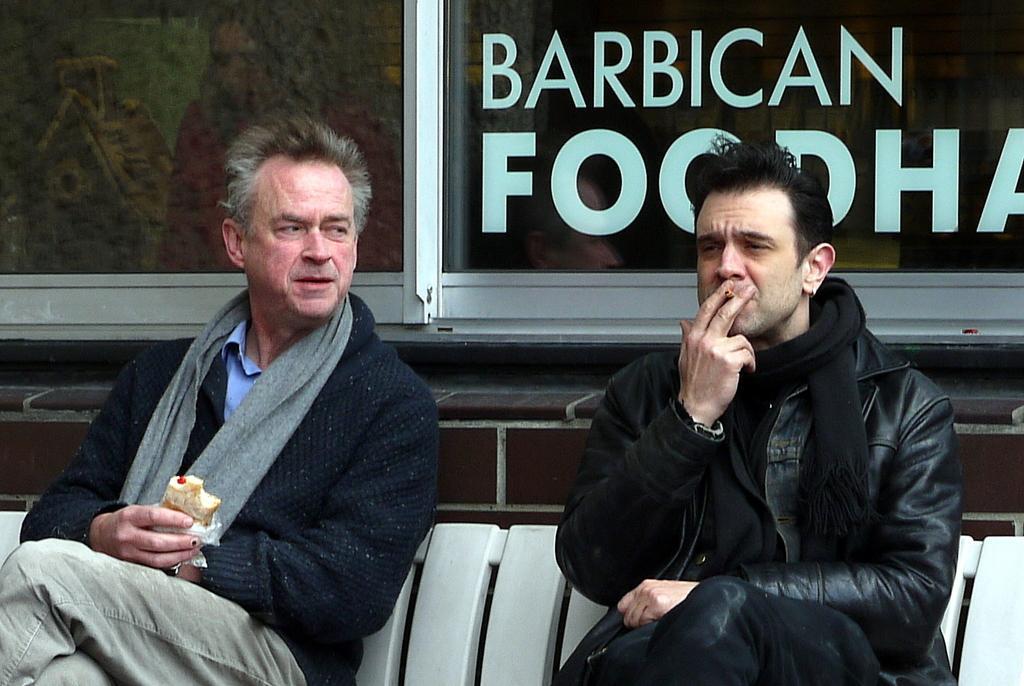Please provide a concise description of this image. In this image I can see two men are sitting. Here I can see both of them are wearing black dress. I can also see he is holding cigarette and he is holding food. In background I can see something is written. 